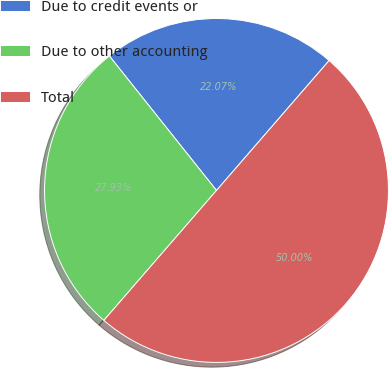Convert chart to OTSL. <chart><loc_0><loc_0><loc_500><loc_500><pie_chart><fcel>Due to credit events or<fcel>Due to other accounting<fcel>Total<nl><fcel>22.07%<fcel>27.93%<fcel>50.0%<nl></chart> 